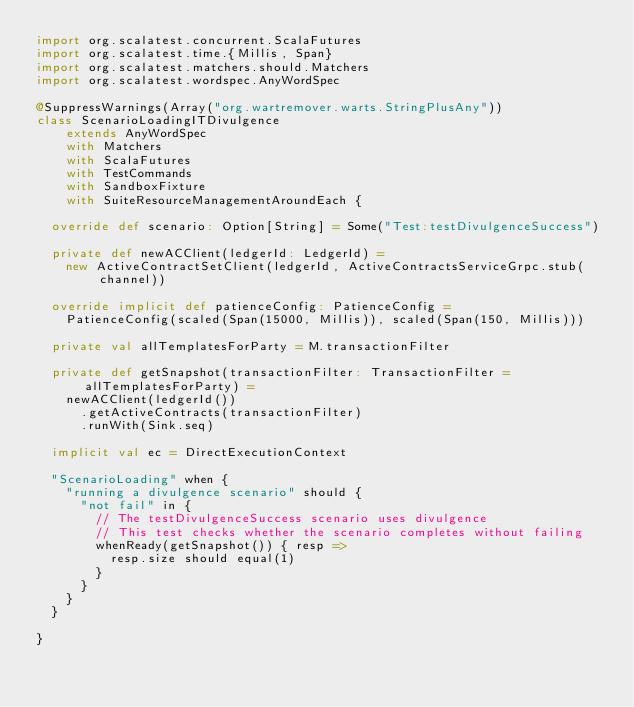Convert code to text. <code><loc_0><loc_0><loc_500><loc_500><_Scala_>import org.scalatest.concurrent.ScalaFutures
import org.scalatest.time.{Millis, Span}
import org.scalatest.matchers.should.Matchers
import org.scalatest.wordspec.AnyWordSpec

@SuppressWarnings(Array("org.wartremover.warts.StringPlusAny"))
class ScenarioLoadingITDivulgence
    extends AnyWordSpec
    with Matchers
    with ScalaFutures
    with TestCommands
    with SandboxFixture
    with SuiteResourceManagementAroundEach {

  override def scenario: Option[String] = Some("Test:testDivulgenceSuccess")

  private def newACClient(ledgerId: LedgerId) =
    new ActiveContractSetClient(ledgerId, ActiveContractsServiceGrpc.stub(channel))

  override implicit def patienceConfig: PatienceConfig =
    PatienceConfig(scaled(Span(15000, Millis)), scaled(Span(150, Millis)))

  private val allTemplatesForParty = M.transactionFilter

  private def getSnapshot(transactionFilter: TransactionFilter = allTemplatesForParty) =
    newACClient(ledgerId())
      .getActiveContracts(transactionFilter)
      .runWith(Sink.seq)

  implicit val ec = DirectExecutionContext

  "ScenarioLoading" when {
    "running a divulgence scenario" should {
      "not fail" in {
        // The testDivulgenceSuccess scenario uses divulgence
        // This test checks whether the scenario completes without failing
        whenReady(getSnapshot()) { resp =>
          resp.size should equal(1)
        }
      }
    }
  }

}
</code> 